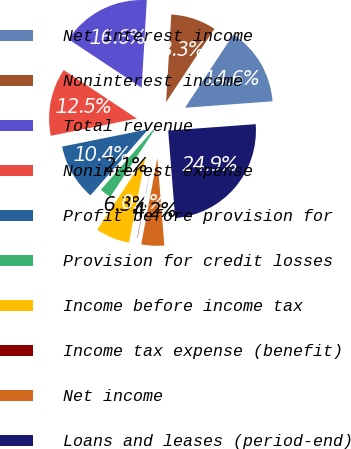<chart> <loc_0><loc_0><loc_500><loc_500><pie_chart><fcel>Net interest income<fcel>Noninterest income<fcel>Total revenue<fcel>Noninterest expense<fcel>Profit before provision for<fcel>Provision for credit losses<fcel>Income before income tax<fcel>Income tax expense (benefit)<fcel>Net income<fcel>Loans and leases (period-end)<nl><fcel>14.55%<fcel>8.34%<fcel>16.62%<fcel>12.48%<fcel>10.41%<fcel>2.14%<fcel>6.28%<fcel>0.07%<fcel>4.21%<fcel>24.9%<nl></chart> 